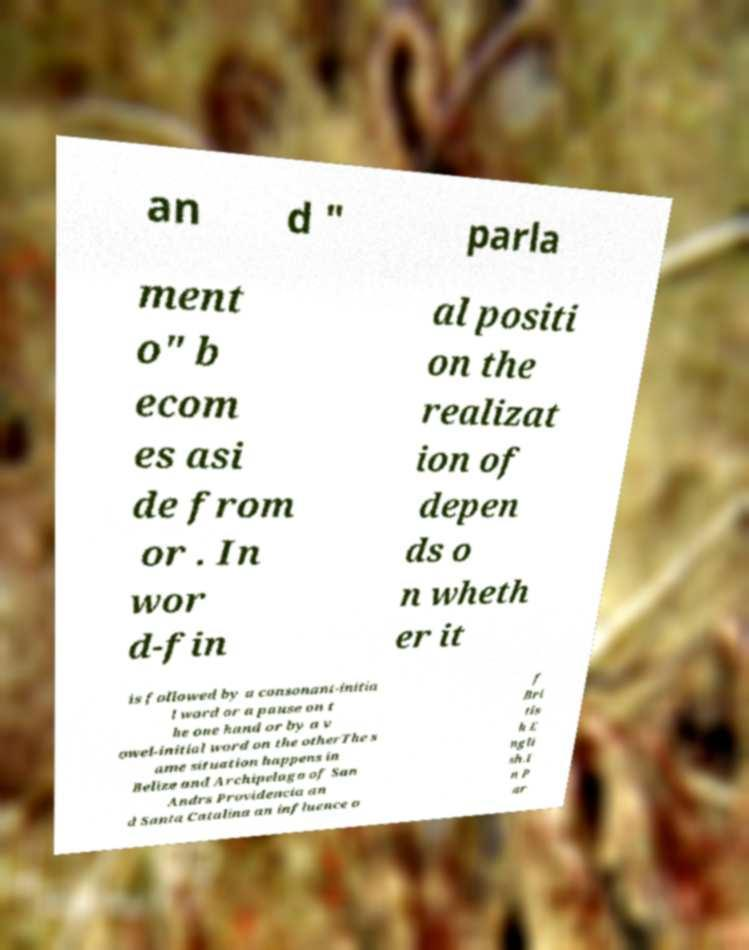Can you read and provide the text displayed in the image?This photo seems to have some interesting text. Can you extract and type it out for me? an d " parla ment o" b ecom es asi de from or . In wor d-fin al positi on the realizat ion of depen ds o n wheth er it is followed by a consonant-initia l word or a pause on t he one hand or by a v owel-initial word on the otherThe s ame situation happens in Belize and Archipelago of San Andrs Providencia an d Santa Catalina an influence o f Bri tis h E ngli sh.I n P ar 